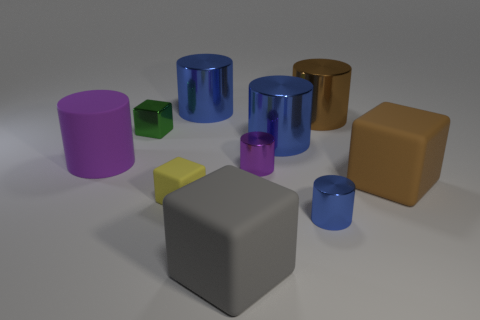Subtract all yellow balls. How many blue cylinders are left? 3 Subtract 1 cylinders. How many cylinders are left? 5 Subtract all brown cylinders. How many cylinders are left? 5 Subtract all small purple shiny cylinders. How many cylinders are left? 5 Subtract all cyan cubes. Subtract all gray cylinders. How many cubes are left? 4 Subtract all cylinders. How many objects are left? 4 Subtract all big purple cylinders. Subtract all red matte spheres. How many objects are left? 9 Add 6 yellow cubes. How many yellow cubes are left? 7 Add 5 large gray balls. How many large gray balls exist? 5 Subtract 1 brown cylinders. How many objects are left? 9 